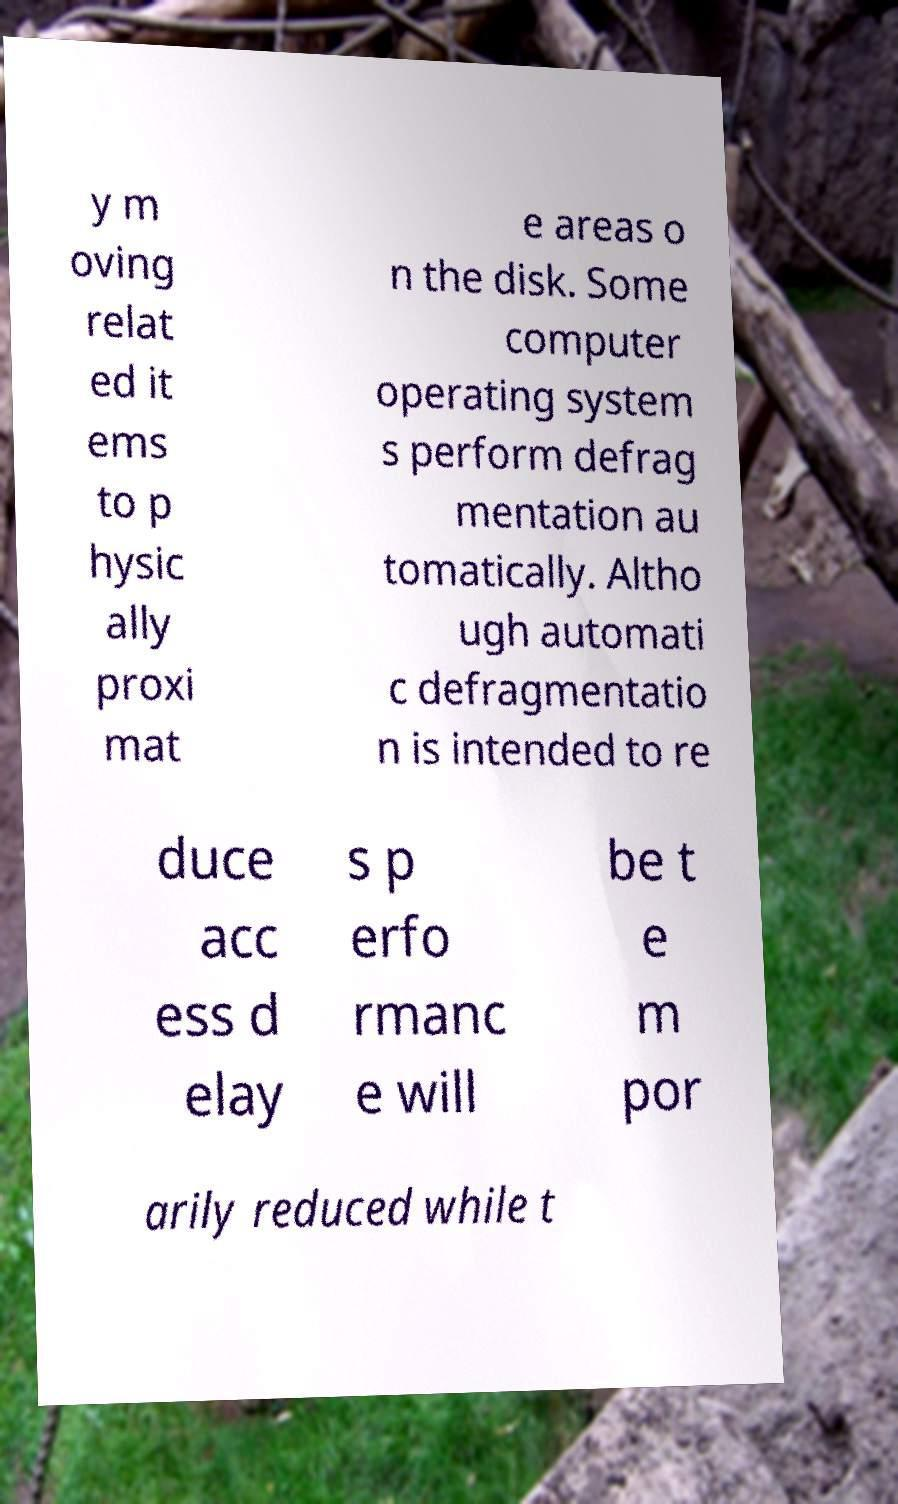Please identify and transcribe the text found in this image. y m oving relat ed it ems to p hysic ally proxi mat e areas o n the disk. Some computer operating system s perform defrag mentation au tomatically. Altho ugh automati c defragmentatio n is intended to re duce acc ess d elay s p erfo rmanc e will be t e m por arily reduced while t 